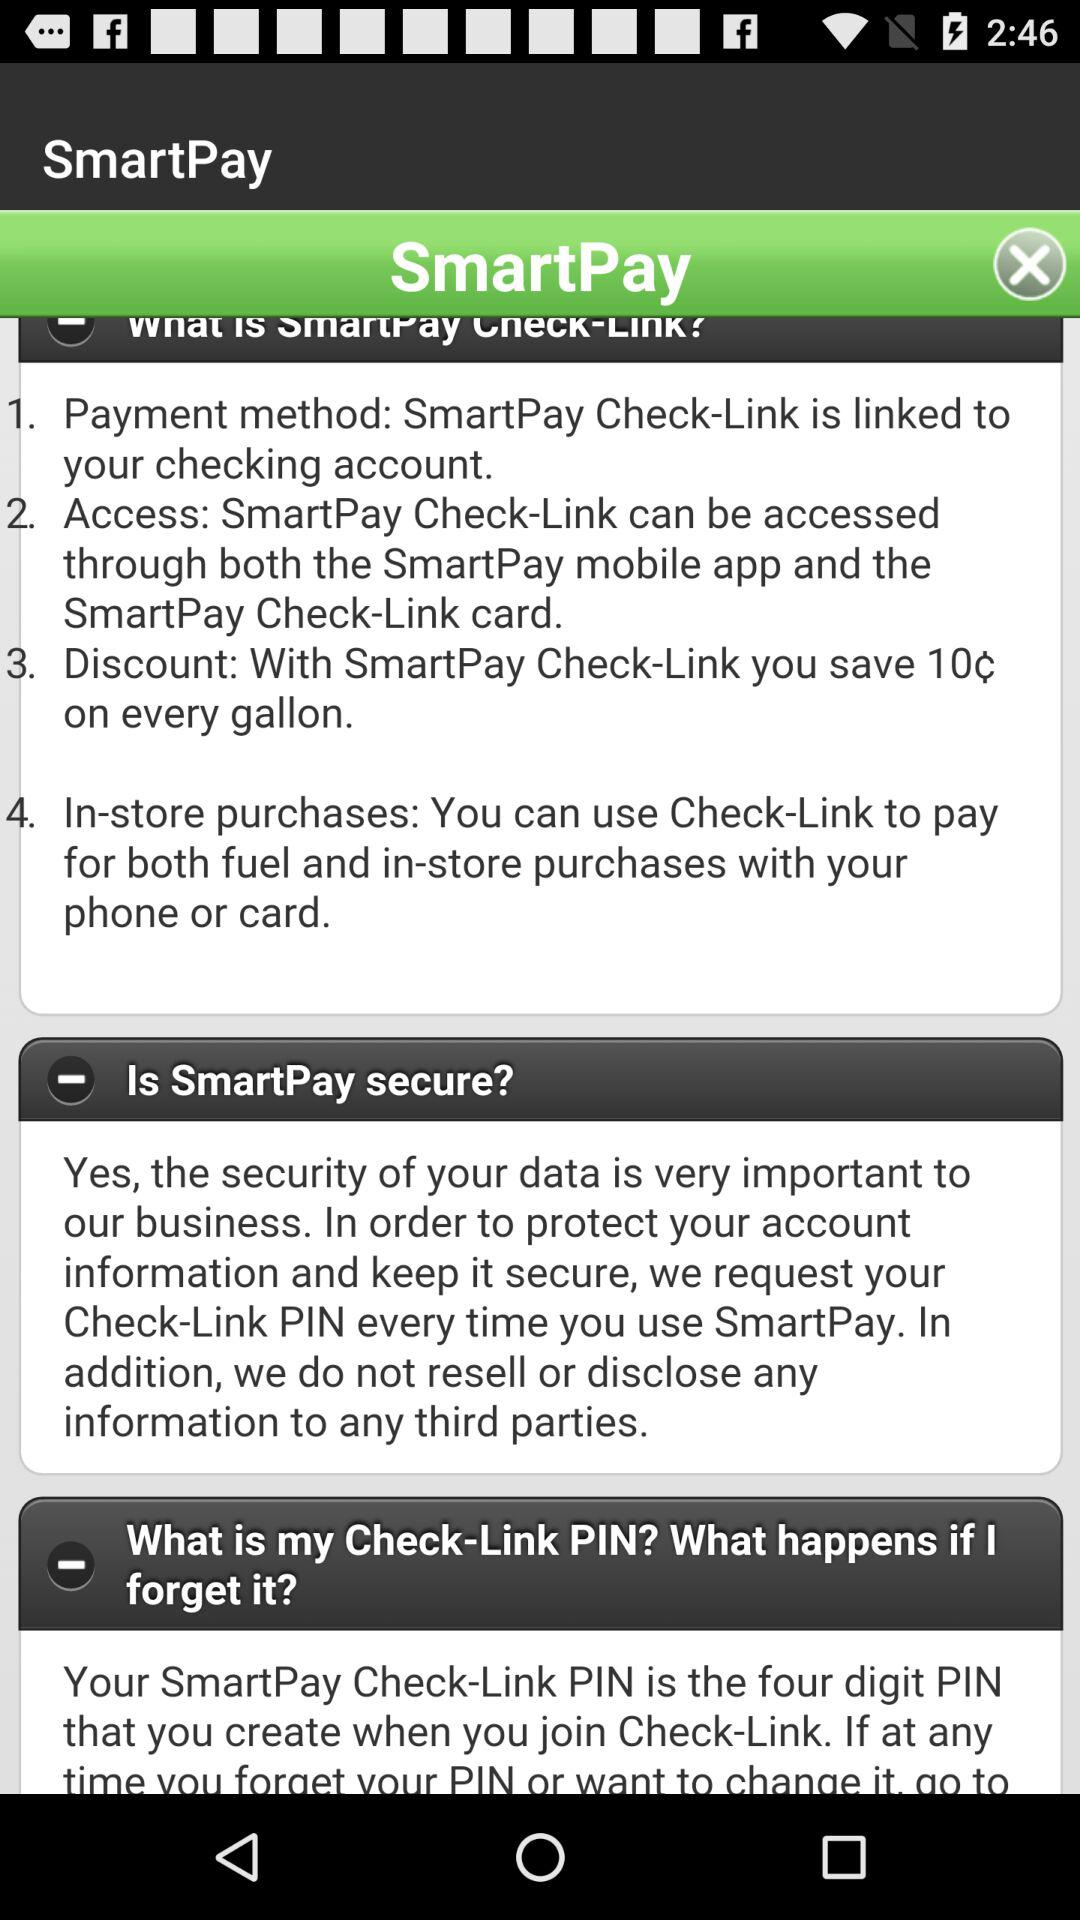How to access "SmartPay" Check-Link? "SmartPay" Check-Link can be accessed through both the "SmartPay" mobile app and the "SmartPay" Check-Link card. 